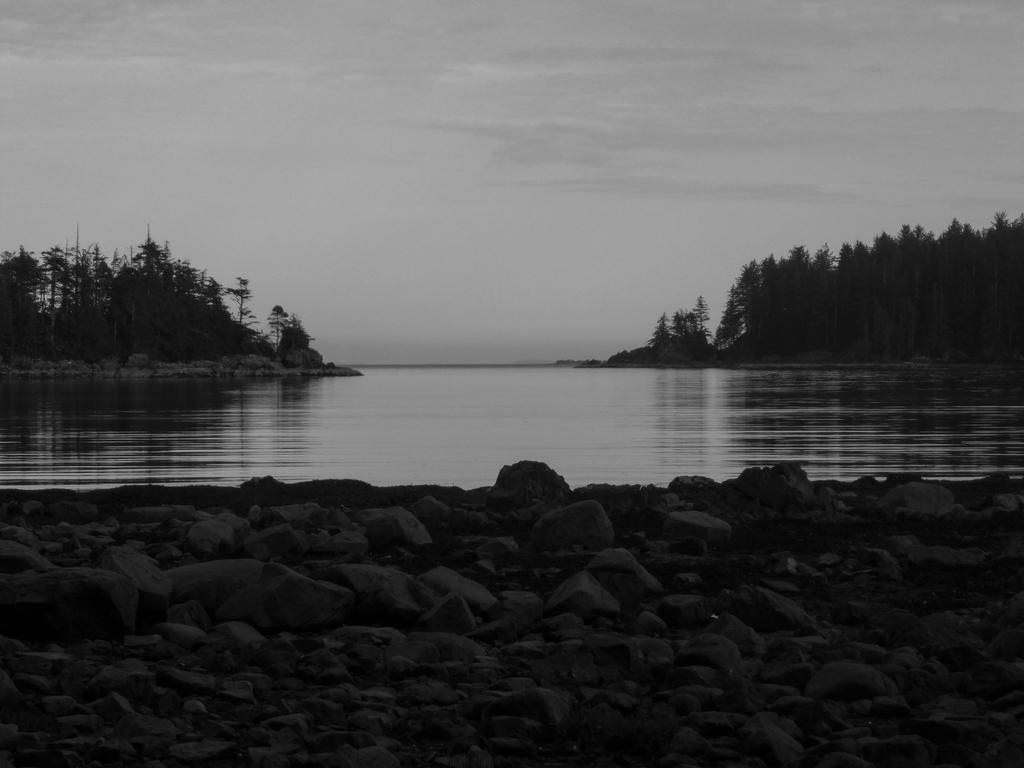Could you give a brief overview of what you see in this image? This picture is clicked outside. In the foreground we can see the rocks and the ground. In the center there is a water body. In the background we can see the sky, trees, plants and rocks. 